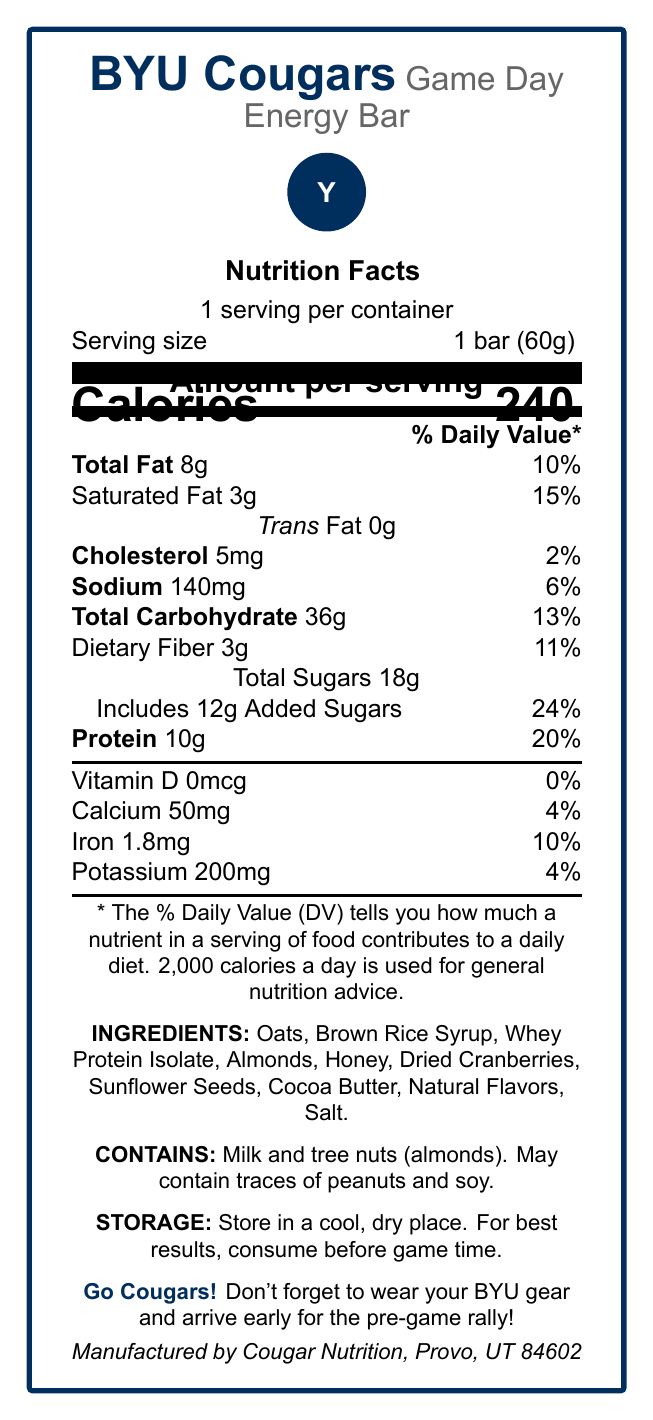what is the serving size for the BYU Cougars Game Day Energy Bar? The serving size is listed at the very beginning of the nutrition facts box as 1 bar (60g).
Answer: 1 bar (60g) how many calories are in one serving of the energy bar? The calories per serving are prominently displayed in large text and are 240.
Answer: 240 what is the total amount of fat in the energy bar? The total fat amount is listed under the nutrition facts, showing 8g.
Answer: 8g what are the ingredients in the energy bar? The ingredient list is provided towards the bottom of the document.
Answer: Oats, Brown Rice Syrup, Whey Protein Isolate, Almonds, Honey, Dried Cranberries, Sunflower Seeds, Cocoa Butter, Natural Flavors, Salt how much protein does the energy bar provide? The protein content is listed under the nutrition facts and is 10g.
Answer: 10g which nutrient contributes the highest % Daily Value? A. Total Fat B. Saturated Fat C. Sodium D. Added Sugars The added sugars have the highest % Daily Value at 24%, compared to other nutrients listed.
Answer: D. Added Sugars which of the following allergens are present in this energy bar? I. Milk II. Peanuts III. Almonds IV. Soy The allergen information states that the bar contains milk and tree nuts (almonds) and may contain traces of peanuts and soy.
Answer: I. Milk and III. Almonds is there any trans fat in the energy bar? The document clearly states that trans fat content is 0g, so there is none.
Answer: No does this energy bar contain any Vitamin D? The Vitamin D content is listed as 0mcg which is 0% of the daily value.
Answer: No summarize the main idea of the document. The document provides comprehensive nutritional information about the BYU Cougars Game Day Energy Bar, detailing the ingredients, allergens, storage instructions, and its benefits for pre-game energy.
Answer: The BYU Cougars Game Day Energy Bar is a nutrition bar marked with the BYU Cougars logo, designed for pre-game energy. It contains 240 calories per serving, with a balanced mix of quick-absorbing carbohydrates, protein, and various nutrients. The bar has a detailed nutritional profile including total fat, saturated fat, cholesterol, sodium, total carbohydrates, dietary fiber, total sugars, added sugars, protein, and several vitamins and minerals. Ingredients and allergen information are also provided. The bar should be stored in a cool, dry place and consumed before game time. what is the Cougar trivia mentioned in the document? The trivia section mentions this specific achievement of the BYU Cougars football team.
Answer: The BYU Cougars football team has won 23 conference championships since 1965. what is the recommended storage condition for the energy bar? The storage instructions state that the bar should be stored in a cool, dry place and are best consumed before the game.
Answer: Store in a cool, dry place. For best results, consume before game time. where is the energy bar manufactured? The document states that the manufacturer is Cougar Nutrition located in Provo, UT 84602.
Answer: Provo, UT 84602 what is the total carbohydrate content in the energy bar? The total carbohydrate content is listed in the nutrition facts as 36g.
Answer: 36g what is the recommended serving suggestion for best results? The storage section suggests consuming the energy bar before game time for best results.
Answer: Consume before game time how much sodium does the energy bar contain? The sodium content is listed in the nutrition facts, showing 140mg.
Answer: 140mg does the energy bar have a QR code, and if so, what is its purpose? The document mentions that the packaging includes a QR code that links to the game day schedule.
Answer: Yes, it links to the game day schedule what is the potassium content in the energy bar? The potassium content is listed in the nutrition facts as 200mg.
Answer: 200mg what is the total amount of sugars in the energy bar, including added sugars? The total sugars are 18g, with 12g coming from added sugars, both amounts are listed in the nutrition facts.
Answer: 18g total, which includes 12g of added sugars how does the bar benefit BYU fans? The document lists key benefits of the energy bar that offer instant energy, muscle support, balanced nutrition, and convenience for BYU fans before a game.
Answer: Quick-absorbing carbohydrates for instant energy, 10g of high-quality protein for muscle support, balanced nutrition to fuel your Cougar spirit, and a convenient pre-game snack to avoid forgetfulness how much calcium is provided per serving of the energy bar? The calcium content is listed in the nutrition facts as 50mg.
Answer: 50mg how many servings are there per container? The serving description mentions that there is 1 serving per container.
Answer: 1 how much dietary fiber is in the energy bar? The dietary fiber content is given in the nutrition facts as 3g.
Answer: 3g was this energy bar made with organic ingredients? The document does not specify whether the ingredients are organic, so it cannot be determined from the given information.
Answer: Not enough information what percentage of the daily value does 3g of saturated fat represent? The document states that 3g of saturated fat is 15% of the daily value.
Answer: 15% does the document remind you to wear BYU gear? The reminder section mentions not to forget to wear BYU gear and arrive early for the pre-game rally.
Answer: Yes 